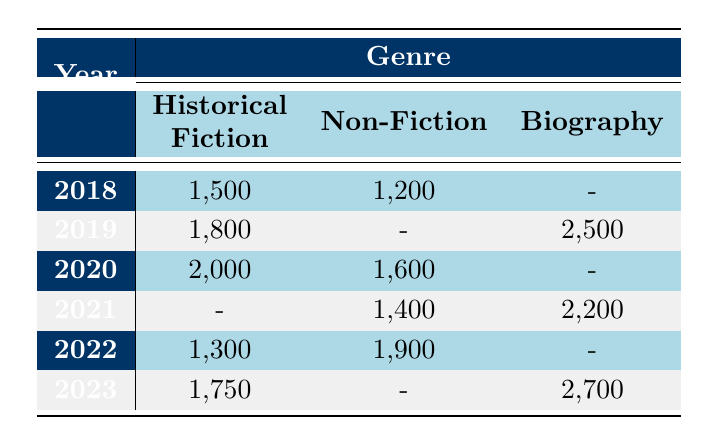What was the highest number of units sold in a single year? The highest number of units sold in a single year can be found by looking at the units sold column for each year. The maximum value is 2,700 from the year 2023 in the Biography genre for the book "Washington: A Life" by Ron Chernow.
Answer: 2700 In 2020, which genre had the most units sold? To find this, we need to compare the units sold for each genre for the year 2020. Historical Fiction had 2,000 units sold, while Non-Fiction had 1,600, and Biography had none listed. Therefore, the genre with the most units sold in 2020 is Historical Fiction.
Answer: Historical Fiction How many units of Non-Fiction books were sold from 2018 to 2023? To answer this, we sum the units sold for Non-Fiction for each year: 1,200 (2018) + 1,600 (2020) + 1,400 (2021) + 1,900 (2022) = 6,100 units. Note that no Non-Fiction books were sold in 2019 and 2023.
Answer: 6100 Was there any year when no Historical Fiction books were sold? Reviewing the table, we see that Historical Fiction had sales in every year from 2018 to 2023, indicating that there was no year without sales in that genre.
Answer: No Which genre had the least amount of total units sold across all years? To find this, we calculate the total units sold for each genre. Historical Fiction: 1,500 + 1,800 + 2,000 + 1,300 + 1,750 = 8,350 units; Non-Fiction: 1,200 + 1,600 + 1,400 + 1,900 + 0 = 6,100 units; Biography: 2,500 + 0 + 2,200 + 0 + 2,700 = 7,400 units. Non-Fiction has the least total units sold of 6,100.
Answer: Non-Fiction What is the average number of units sold for Historical Fiction books over the years listed? First, we sum the Historical Fiction units sold: 1,500 (2018) + 1,800 (2019) + 2,000 (2020) + 1,300 (2022) + 1,750 (2023) = 8,350 units. These data points (5 years) provide an average of 8,350/5 = 1,670.
Answer: 1670 